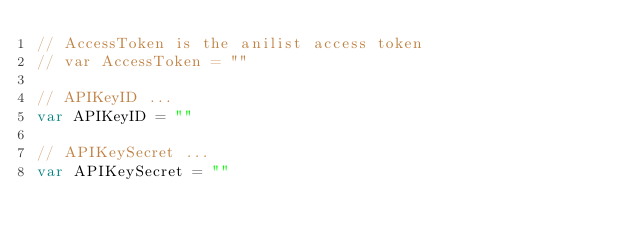Convert code to text. <code><loc_0><loc_0><loc_500><loc_500><_Go_>// AccessToken is the anilist access token
// var AccessToken = ""

// APIKeyID ...
var APIKeyID = ""

// APIKeySecret ...
var APIKeySecret = ""
</code> 